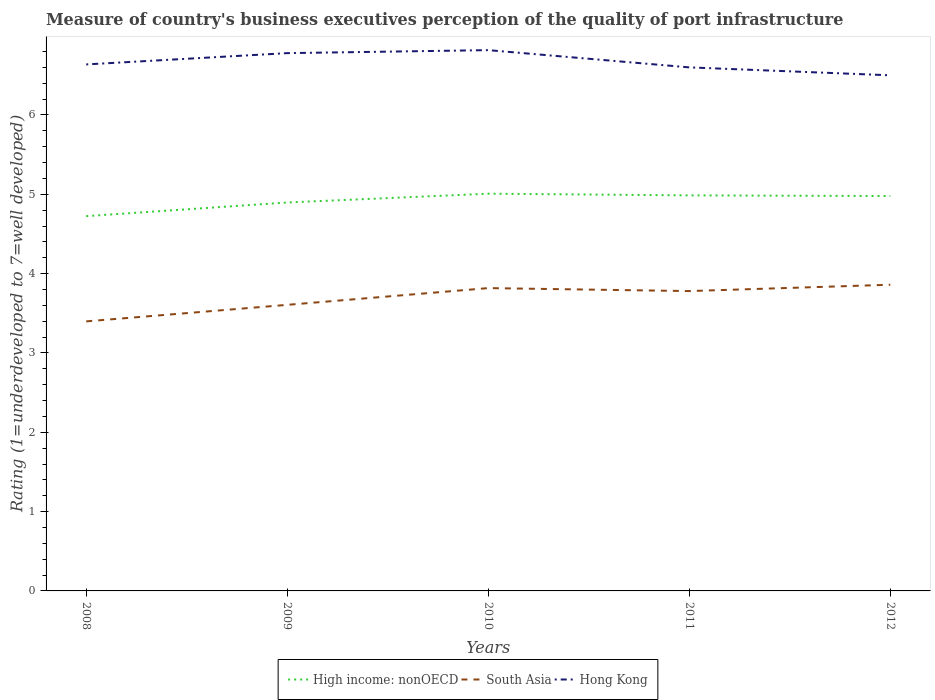How many different coloured lines are there?
Keep it short and to the point. 3. Does the line corresponding to South Asia intersect with the line corresponding to Hong Kong?
Your answer should be very brief. No. Is the number of lines equal to the number of legend labels?
Make the answer very short. Yes. Across all years, what is the maximum ratings of the quality of port infrastructure in Hong Kong?
Ensure brevity in your answer.  6.5. What is the total ratings of the quality of port infrastructure in High income: nonOECD in the graph?
Provide a succinct answer. -0.11. What is the difference between the highest and the second highest ratings of the quality of port infrastructure in High income: nonOECD?
Provide a short and direct response. 0.28. What is the difference between the highest and the lowest ratings of the quality of port infrastructure in Hong Kong?
Provide a short and direct response. 2. How many lines are there?
Offer a terse response. 3. What is the difference between two consecutive major ticks on the Y-axis?
Keep it short and to the point. 1. Are the values on the major ticks of Y-axis written in scientific E-notation?
Ensure brevity in your answer.  No. Does the graph contain any zero values?
Your answer should be very brief. No. Where does the legend appear in the graph?
Your response must be concise. Bottom center. How many legend labels are there?
Your answer should be compact. 3. How are the legend labels stacked?
Your answer should be very brief. Horizontal. What is the title of the graph?
Ensure brevity in your answer.  Measure of country's business executives perception of the quality of port infrastructure. What is the label or title of the X-axis?
Your response must be concise. Years. What is the label or title of the Y-axis?
Your answer should be compact. Rating (1=underdeveloped to 7=well developed). What is the Rating (1=underdeveloped to 7=well developed) of High income: nonOECD in 2008?
Your response must be concise. 4.72. What is the Rating (1=underdeveloped to 7=well developed) in South Asia in 2008?
Ensure brevity in your answer.  3.4. What is the Rating (1=underdeveloped to 7=well developed) in Hong Kong in 2008?
Ensure brevity in your answer.  6.64. What is the Rating (1=underdeveloped to 7=well developed) of High income: nonOECD in 2009?
Provide a succinct answer. 4.9. What is the Rating (1=underdeveloped to 7=well developed) in South Asia in 2009?
Give a very brief answer. 3.61. What is the Rating (1=underdeveloped to 7=well developed) of Hong Kong in 2009?
Offer a terse response. 6.78. What is the Rating (1=underdeveloped to 7=well developed) of High income: nonOECD in 2010?
Your answer should be very brief. 5.01. What is the Rating (1=underdeveloped to 7=well developed) of South Asia in 2010?
Your response must be concise. 3.82. What is the Rating (1=underdeveloped to 7=well developed) of Hong Kong in 2010?
Provide a succinct answer. 6.82. What is the Rating (1=underdeveloped to 7=well developed) in High income: nonOECD in 2011?
Offer a very short reply. 4.99. What is the Rating (1=underdeveloped to 7=well developed) of South Asia in 2011?
Ensure brevity in your answer.  3.78. What is the Rating (1=underdeveloped to 7=well developed) in High income: nonOECD in 2012?
Ensure brevity in your answer.  4.98. What is the Rating (1=underdeveloped to 7=well developed) of South Asia in 2012?
Make the answer very short. 3.86. Across all years, what is the maximum Rating (1=underdeveloped to 7=well developed) of High income: nonOECD?
Provide a short and direct response. 5.01. Across all years, what is the maximum Rating (1=underdeveloped to 7=well developed) of South Asia?
Your response must be concise. 3.86. Across all years, what is the maximum Rating (1=underdeveloped to 7=well developed) in Hong Kong?
Give a very brief answer. 6.82. Across all years, what is the minimum Rating (1=underdeveloped to 7=well developed) in High income: nonOECD?
Provide a succinct answer. 4.72. Across all years, what is the minimum Rating (1=underdeveloped to 7=well developed) in South Asia?
Ensure brevity in your answer.  3.4. Across all years, what is the minimum Rating (1=underdeveloped to 7=well developed) of Hong Kong?
Your answer should be compact. 6.5. What is the total Rating (1=underdeveloped to 7=well developed) in High income: nonOECD in the graph?
Provide a short and direct response. 24.59. What is the total Rating (1=underdeveloped to 7=well developed) in South Asia in the graph?
Keep it short and to the point. 18.46. What is the total Rating (1=underdeveloped to 7=well developed) of Hong Kong in the graph?
Keep it short and to the point. 33.33. What is the difference between the Rating (1=underdeveloped to 7=well developed) of High income: nonOECD in 2008 and that in 2009?
Provide a succinct answer. -0.17. What is the difference between the Rating (1=underdeveloped to 7=well developed) of South Asia in 2008 and that in 2009?
Provide a succinct answer. -0.21. What is the difference between the Rating (1=underdeveloped to 7=well developed) of Hong Kong in 2008 and that in 2009?
Your answer should be compact. -0.14. What is the difference between the Rating (1=underdeveloped to 7=well developed) of High income: nonOECD in 2008 and that in 2010?
Your response must be concise. -0.28. What is the difference between the Rating (1=underdeveloped to 7=well developed) in South Asia in 2008 and that in 2010?
Ensure brevity in your answer.  -0.42. What is the difference between the Rating (1=underdeveloped to 7=well developed) in Hong Kong in 2008 and that in 2010?
Provide a succinct answer. -0.18. What is the difference between the Rating (1=underdeveloped to 7=well developed) in High income: nonOECD in 2008 and that in 2011?
Provide a short and direct response. -0.26. What is the difference between the Rating (1=underdeveloped to 7=well developed) in South Asia in 2008 and that in 2011?
Ensure brevity in your answer.  -0.38. What is the difference between the Rating (1=underdeveloped to 7=well developed) in Hong Kong in 2008 and that in 2011?
Ensure brevity in your answer.  0.04. What is the difference between the Rating (1=underdeveloped to 7=well developed) of High income: nonOECD in 2008 and that in 2012?
Your answer should be very brief. -0.25. What is the difference between the Rating (1=underdeveloped to 7=well developed) of South Asia in 2008 and that in 2012?
Provide a short and direct response. -0.46. What is the difference between the Rating (1=underdeveloped to 7=well developed) in Hong Kong in 2008 and that in 2012?
Your response must be concise. 0.14. What is the difference between the Rating (1=underdeveloped to 7=well developed) of High income: nonOECD in 2009 and that in 2010?
Your answer should be very brief. -0.11. What is the difference between the Rating (1=underdeveloped to 7=well developed) of South Asia in 2009 and that in 2010?
Make the answer very short. -0.21. What is the difference between the Rating (1=underdeveloped to 7=well developed) of Hong Kong in 2009 and that in 2010?
Offer a very short reply. -0.04. What is the difference between the Rating (1=underdeveloped to 7=well developed) of High income: nonOECD in 2009 and that in 2011?
Provide a short and direct response. -0.09. What is the difference between the Rating (1=underdeveloped to 7=well developed) of South Asia in 2009 and that in 2011?
Your answer should be very brief. -0.17. What is the difference between the Rating (1=underdeveloped to 7=well developed) in Hong Kong in 2009 and that in 2011?
Offer a very short reply. 0.18. What is the difference between the Rating (1=underdeveloped to 7=well developed) of High income: nonOECD in 2009 and that in 2012?
Make the answer very short. -0.08. What is the difference between the Rating (1=underdeveloped to 7=well developed) of South Asia in 2009 and that in 2012?
Make the answer very short. -0.25. What is the difference between the Rating (1=underdeveloped to 7=well developed) of Hong Kong in 2009 and that in 2012?
Give a very brief answer. 0.28. What is the difference between the Rating (1=underdeveloped to 7=well developed) of High income: nonOECD in 2010 and that in 2011?
Your answer should be very brief. 0.02. What is the difference between the Rating (1=underdeveloped to 7=well developed) in South Asia in 2010 and that in 2011?
Provide a succinct answer. 0.04. What is the difference between the Rating (1=underdeveloped to 7=well developed) of Hong Kong in 2010 and that in 2011?
Offer a terse response. 0.22. What is the difference between the Rating (1=underdeveloped to 7=well developed) of High income: nonOECD in 2010 and that in 2012?
Your response must be concise. 0.03. What is the difference between the Rating (1=underdeveloped to 7=well developed) in South Asia in 2010 and that in 2012?
Keep it short and to the point. -0.04. What is the difference between the Rating (1=underdeveloped to 7=well developed) in Hong Kong in 2010 and that in 2012?
Your answer should be very brief. 0.32. What is the difference between the Rating (1=underdeveloped to 7=well developed) in High income: nonOECD in 2011 and that in 2012?
Provide a short and direct response. 0.01. What is the difference between the Rating (1=underdeveloped to 7=well developed) in South Asia in 2011 and that in 2012?
Provide a short and direct response. -0.08. What is the difference between the Rating (1=underdeveloped to 7=well developed) of Hong Kong in 2011 and that in 2012?
Keep it short and to the point. 0.1. What is the difference between the Rating (1=underdeveloped to 7=well developed) in High income: nonOECD in 2008 and the Rating (1=underdeveloped to 7=well developed) in South Asia in 2009?
Your response must be concise. 1.12. What is the difference between the Rating (1=underdeveloped to 7=well developed) of High income: nonOECD in 2008 and the Rating (1=underdeveloped to 7=well developed) of Hong Kong in 2009?
Offer a terse response. -2.06. What is the difference between the Rating (1=underdeveloped to 7=well developed) of South Asia in 2008 and the Rating (1=underdeveloped to 7=well developed) of Hong Kong in 2009?
Keep it short and to the point. -3.38. What is the difference between the Rating (1=underdeveloped to 7=well developed) in High income: nonOECD in 2008 and the Rating (1=underdeveloped to 7=well developed) in South Asia in 2010?
Give a very brief answer. 0.91. What is the difference between the Rating (1=underdeveloped to 7=well developed) in High income: nonOECD in 2008 and the Rating (1=underdeveloped to 7=well developed) in Hong Kong in 2010?
Ensure brevity in your answer.  -2.09. What is the difference between the Rating (1=underdeveloped to 7=well developed) in South Asia in 2008 and the Rating (1=underdeveloped to 7=well developed) in Hong Kong in 2010?
Your response must be concise. -3.42. What is the difference between the Rating (1=underdeveloped to 7=well developed) in High income: nonOECD in 2008 and the Rating (1=underdeveloped to 7=well developed) in South Asia in 2011?
Give a very brief answer. 0.94. What is the difference between the Rating (1=underdeveloped to 7=well developed) in High income: nonOECD in 2008 and the Rating (1=underdeveloped to 7=well developed) in Hong Kong in 2011?
Your answer should be very brief. -1.88. What is the difference between the Rating (1=underdeveloped to 7=well developed) of South Asia in 2008 and the Rating (1=underdeveloped to 7=well developed) of Hong Kong in 2011?
Your answer should be very brief. -3.2. What is the difference between the Rating (1=underdeveloped to 7=well developed) in High income: nonOECD in 2008 and the Rating (1=underdeveloped to 7=well developed) in South Asia in 2012?
Keep it short and to the point. 0.86. What is the difference between the Rating (1=underdeveloped to 7=well developed) of High income: nonOECD in 2008 and the Rating (1=underdeveloped to 7=well developed) of Hong Kong in 2012?
Your answer should be very brief. -1.78. What is the difference between the Rating (1=underdeveloped to 7=well developed) of South Asia in 2008 and the Rating (1=underdeveloped to 7=well developed) of Hong Kong in 2012?
Provide a short and direct response. -3.1. What is the difference between the Rating (1=underdeveloped to 7=well developed) in High income: nonOECD in 2009 and the Rating (1=underdeveloped to 7=well developed) in South Asia in 2010?
Make the answer very short. 1.08. What is the difference between the Rating (1=underdeveloped to 7=well developed) in High income: nonOECD in 2009 and the Rating (1=underdeveloped to 7=well developed) in Hong Kong in 2010?
Offer a very short reply. -1.92. What is the difference between the Rating (1=underdeveloped to 7=well developed) in South Asia in 2009 and the Rating (1=underdeveloped to 7=well developed) in Hong Kong in 2010?
Keep it short and to the point. -3.21. What is the difference between the Rating (1=underdeveloped to 7=well developed) of High income: nonOECD in 2009 and the Rating (1=underdeveloped to 7=well developed) of South Asia in 2011?
Give a very brief answer. 1.12. What is the difference between the Rating (1=underdeveloped to 7=well developed) in High income: nonOECD in 2009 and the Rating (1=underdeveloped to 7=well developed) in Hong Kong in 2011?
Your answer should be very brief. -1.7. What is the difference between the Rating (1=underdeveloped to 7=well developed) in South Asia in 2009 and the Rating (1=underdeveloped to 7=well developed) in Hong Kong in 2011?
Make the answer very short. -2.99. What is the difference between the Rating (1=underdeveloped to 7=well developed) in High income: nonOECD in 2009 and the Rating (1=underdeveloped to 7=well developed) in South Asia in 2012?
Keep it short and to the point. 1.04. What is the difference between the Rating (1=underdeveloped to 7=well developed) in High income: nonOECD in 2009 and the Rating (1=underdeveloped to 7=well developed) in Hong Kong in 2012?
Your answer should be compact. -1.6. What is the difference between the Rating (1=underdeveloped to 7=well developed) in South Asia in 2009 and the Rating (1=underdeveloped to 7=well developed) in Hong Kong in 2012?
Your response must be concise. -2.89. What is the difference between the Rating (1=underdeveloped to 7=well developed) of High income: nonOECD in 2010 and the Rating (1=underdeveloped to 7=well developed) of South Asia in 2011?
Ensure brevity in your answer.  1.23. What is the difference between the Rating (1=underdeveloped to 7=well developed) in High income: nonOECD in 2010 and the Rating (1=underdeveloped to 7=well developed) in Hong Kong in 2011?
Offer a terse response. -1.59. What is the difference between the Rating (1=underdeveloped to 7=well developed) of South Asia in 2010 and the Rating (1=underdeveloped to 7=well developed) of Hong Kong in 2011?
Keep it short and to the point. -2.78. What is the difference between the Rating (1=underdeveloped to 7=well developed) in High income: nonOECD in 2010 and the Rating (1=underdeveloped to 7=well developed) in South Asia in 2012?
Provide a short and direct response. 1.15. What is the difference between the Rating (1=underdeveloped to 7=well developed) of High income: nonOECD in 2010 and the Rating (1=underdeveloped to 7=well developed) of Hong Kong in 2012?
Keep it short and to the point. -1.49. What is the difference between the Rating (1=underdeveloped to 7=well developed) in South Asia in 2010 and the Rating (1=underdeveloped to 7=well developed) in Hong Kong in 2012?
Your answer should be compact. -2.68. What is the difference between the Rating (1=underdeveloped to 7=well developed) of High income: nonOECD in 2011 and the Rating (1=underdeveloped to 7=well developed) of South Asia in 2012?
Give a very brief answer. 1.13. What is the difference between the Rating (1=underdeveloped to 7=well developed) in High income: nonOECD in 2011 and the Rating (1=underdeveloped to 7=well developed) in Hong Kong in 2012?
Offer a very short reply. -1.51. What is the difference between the Rating (1=underdeveloped to 7=well developed) in South Asia in 2011 and the Rating (1=underdeveloped to 7=well developed) in Hong Kong in 2012?
Your answer should be compact. -2.72. What is the average Rating (1=underdeveloped to 7=well developed) of High income: nonOECD per year?
Offer a very short reply. 4.92. What is the average Rating (1=underdeveloped to 7=well developed) of South Asia per year?
Make the answer very short. 3.69. What is the average Rating (1=underdeveloped to 7=well developed) of Hong Kong per year?
Your answer should be compact. 6.67. In the year 2008, what is the difference between the Rating (1=underdeveloped to 7=well developed) of High income: nonOECD and Rating (1=underdeveloped to 7=well developed) of South Asia?
Provide a short and direct response. 1.33. In the year 2008, what is the difference between the Rating (1=underdeveloped to 7=well developed) of High income: nonOECD and Rating (1=underdeveloped to 7=well developed) of Hong Kong?
Provide a short and direct response. -1.91. In the year 2008, what is the difference between the Rating (1=underdeveloped to 7=well developed) in South Asia and Rating (1=underdeveloped to 7=well developed) in Hong Kong?
Ensure brevity in your answer.  -3.24. In the year 2009, what is the difference between the Rating (1=underdeveloped to 7=well developed) in High income: nonOECD and Rating (1=underdeveloped to 7=well developed) in South Asia?
Offer a very short reply. 1.29. In the year 2009, what is the difference between the Rating (1=underdeveloped to 7=well developed) in High income: nonOECD and Rating (1=underdeveloped to 7=well developed) in Hong Kong?
Your answer should be very brief. -1.88. In the year 2009, what is the difference between the Rating (1=underdeveloped to 7=well developed) in South Asia and Rating (1=underdeveloped to 7=well developed) in Hong Kong?
Offer a very short reply. -3.17. In the year 2010, what is the difference between the Rating (1=underdeveloped to 7=well developed) in High income: nonOECD and Rating (1=underdeveloped to 7=well developed) in South Asia?
Offer a terse response. 1.19. In the year 2010, what is the difference between the Rating (1=underdeveloped to 7=well developed) of High income: nonOECD and Rating (1=underdeveloped to 7=well developed) of Hong Kong?
Make the answer very short. -1.81. In the year 2010, what is the difference between the Rating (1=underdeveloped to 7=well developed) in South Asia and Rating (1=underdeveloped to 7=well developed) in Hong Kong?
Keep it short and to the point. -3. In the year 2011, what is the difference between the Rating (1=underdeveloped to 7=well developed) in High income: nonOECD and Rating (1=underdeveloped to 7=well developed) in South Asia?
Provide a succinct answer. 1.21. In the year 2011, what is the difference between the Rating (1=underdeveloped to 7=well developed) of High income: nonOECD and Rating (1=underdeveloped to 7=well developed) of Hong Kong?
Keep it short and to the point. -1.61. In the year 2011, what is the difference between the Rating (1=underdeveloped to 7=well developed) of South Asia and Rating (1=underdeveloped to 7=well developed) of Hong Kong?
Your answer should be compact. -2.82. In the year 2012, what is the difference between the Rating (1=underdeveloped to 7=well developed) of High income: nonOECD and Rating (1=underdeveloped to 7=well developed) of South Asia?
Make the answer very short. 1.12. In the year 2012, what is the difference between the Rating (1=underdeveloped to 7=well developed) of High income: nonOECD and Rating (1=underdeveloped to 7=well developed) of Hong Kong?
Provide a succinct answer. -1.52. In the year 2012, what is the difference between the Rating (1=underdeveloped to 7=well developed) of South Asia and Rating (1=underdeveloped to 7=well developed) of Hong Kong?
Your answer should be very brief. -2.64. What is the ratio of the Rating (1=underdeveloped to 7=well developed) of High income: nonOECD in 2008 to that in 2009?
Your answer should be very brief. 0.96. What is the ratio of the Rating (1=underdeveloped to 7=well developed) of South Asia in 2008 to that in 2009?
Your response must be concise. 0.94. What is the ratio of the Rating (1=underdeveloped to 7=well developed) of High income: nonOECD in 2008 to that in 2010?
Make the answer very short. 0.94. What is the ratio of the Rating (1=underdeveloped to 7=well developed) of South Asia in 2008 to that in 2010?
Ensure brevity in your answer.  0.89. What is the ratio of the Rating (1=underdeveloped to 7=well developed) of Hong Kong in 2008 to that in 2010?
Provide a short and direct response. 0.97. What is the ratio of the Rating (1=underdeveloped to 7=well developed) of High income: nonOECD in 2008 to that in 2011?
Your response must be concise. 0.95. What is the ratio of the Rating (1=underdeveloped to 7=well developed) of South Asia in 2008 to that in 2011?
Give a very brief answer. 0.9. What is the ratio of the Rating (1=underdeveloped to 7=well developed) in High income: nonOECD in 2008 to that in 2012?
Give a very brief answer. 0.95. What is the ratio of the Rating (1=underdeveloped to 7=well developed) of South Asia in 2008 to that in 2012?
Ensure brevity in your answer.  0.88. What is the ratio of the Rating (1=underdeveloped to 7=well developed) of Hong Kong in 2008 to that in 2012?
Ensure brevity in your answer.  1.02. What is the ratio of the Rating (1=underdeveloped to 7=well developed) in High income: nonOECD in 2009 to that in 2010?
Your answer should be very brief. 0.98. What is the ratio of the Rating (1=underdeveloped to 7=well developed) of South Asia in 2009 to that in 2010?
Provide a short and direct response. 0.94. What is the ratio of the Rating (1=underdeveloped to 7=well developed) in Hong Kong in 2009 to that in 2010?
Ensure brevity in your answer.  0.99. What is the ratio of the Rating (1=underdeveloped to 7=well developed) of High income: nonOECD in 2009 to that in 2011?
Offer a terse response. 0.98. What is the ratio of the Rating (1=underdeveloped to 7=well developed) of South Asia in 2009 to that in 2011?
Give a very brief answer. 0.95. What is the ratio of the Rating (1=underdeveloped to 7=well developed) in Hong Kong in 2009 to that in 2011?
Ensure brevity in your answer.  1.03. What is the ratio of the Rating (1=underdeveloped to 7=well developed) of High income: nonOECD in 2009 to that in 2012?
Give a very brief answer. 0.98. What is the ratio of the Rating (1=underdeveloped to 7=well developed) in South Asia in 2009 to that in 2012?
Offer a very short reply. 0.93. What is the ratio of the Rating (1=underdeveloped to 7=well developed) of Hong Kong in 2009 to that in 2012?
Your response must be concise. 1.04. What is the ratio of the Rating (1=underdeveloped to 7=well developed) in High income: nonOECD in 2010 to that in 2011?
Your response must be concise. 1. What is the ratio of the Rating (1=underdeveloped to 7=well developed) in South Asia in 2010 to that in 2011?
Keep it short and to the point. 1.01. What is the ratio of the Rating (1=underdeveloped to 7=well developed) of Hong Kong in 2010 to that in 2011?
Make the answer very short. 1.03. What is the ratio of the Rating (1=underdeveloped to 7=well developed) of High income: nonOECD in 2010 to that in 2012?
Your response must be concise. 1.01. What is the ratio of the Rating (1=underdeveloped to 7=well developed) of South Asia in 2010 to that in 2012?
Make the answer very short. 0.99. What is the ratio of the Rating (1=underdeveloped to 7=well developed) in Hong Kong in 2010 to that in 2012?
Ensure brevity in your answer.  1.05. What is the ratio of the Rating (1=underdeveloped to 7=well developed) in South Asia in 2011 to that in 2012?
Give a very brief answer. 0.98. What is the ratio of the Rating (1=underdeveloped to 7=well developed) of Hong Kong in 2011 to that in 2012?
Keep it short and to the point. 1.02. What is the difference between the highest and the second highest Rating (1=underdeveloped to 7=well developed) of High income: nonOECD?
Offer a terse response. 0.02. What is the difference between the highest and the second highest Rating (1=underdeveloped to 7=well developed) of South Asia?
Provide a short and direct response. 0.04. What is the difference between the highest and the second highest Rating (1=underdeveloped to 7=well developed) of Hong Kong?
Provide a short and direct response. 0.04. What is the difference between the highest and the lowest Rating (1=underdeveloped to 7=well developed) of High income: nonOECD?
Provide a succinct answer. 0.28. What is the difference between the highest and the lowest Rating (1=underdeveloped to 7=well developed) in South Asia?
Your answer should be very brief. 0.46. What is the difference between the highest and the lowest Rating (1=underdeveloped to 7=well developed) in Hong Kong?
Give a very brief answer. 0.32. 